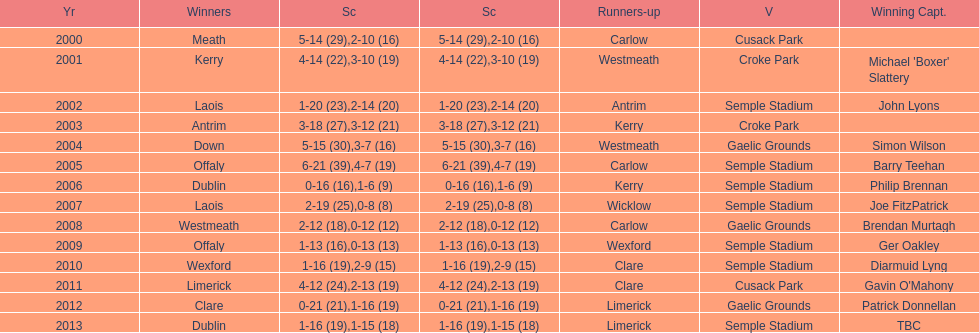Could you parse the entire table as a dict? {'header': ['Yr', 'Winners', 'Sc', 'Sc', 'Runners-up', 'V', 'Winning Capt.'], 'rows': [['2000', 'Meath', '5-14 (29)', '2-10 (16)', 'Carlow', 'Cusack Park', ''], ['2001', 'Kerry', '4-14 (22)', '3-10 (19)', 'Westmeath', 'Croke Park', "Michael 'Boxer' Slattery"], ['2002', 'Laois', '1-20 (23)', '2-14 (20)', 'Antrim', 'Semple Stadium', 'John Lyons'], ['2003', 'Antrim', '3-18 (27)', '3-12 (21)', 'Kerry', 'Croke Park', ''], ['2004', 'Down', '5-15 (30)', '3-7 (16)', 'Westmeath', 'Gaelic Grounds', 'Simon Wilson'], ['2005', 'Offaly', '6-21 (39)', '4-7 (19)', 'Carlow', 'Semple Stadium', 'Barry Teehan'], ['2006', 'Dublin', '0-16 (16)', '1-6 (9)', 'Kerry', 'Semple Stadium', 'Philip Brennan'], ['2007', 'Laois', '2-19 (25)', '0-8 (8)', 'Wicklow', 'Semple Stadium', 'Joe FitzPatrick'], ['2008', 'Westmeath', '2-12 (18)', '0-12 (12)', 'Carlow', 'Gaelic Grounds', 'Brendan Murtagh'], ['2009', 'Offaly', '1-13 (16)', '0-13 (13)', 'Wexford', 'Semple Stadium', 'Ger Oakley'], ['2010', 'Wexford', '1-16 (19)', '2-9 (15)', 'Clare', 'Semple Stadium', 'Diarmuid Lyng'], ['2011', 'Limerick', '4-12 (24)', '2-13 (19)', 'Clare', 'Cusack Park', "Gavin O'Mahony"], ['2012', 'Clare', '0-21 (21)', '1-16 (19)', 'Limerick', 'Gaelic Grounds', 'Patrick Donnellan'], ['2013', 'Dublin', '1-16 (19)', '1-15 (18)', 'Limerick', 'Semple Stadium', 'TBC']]} What is the total number of times the competition was held at the semple stadium venue? 7. 